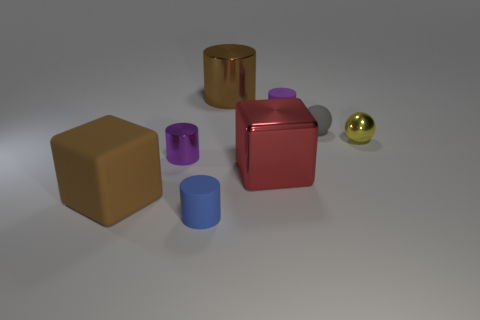Subtract all green cylinders. Subtract all purple spheres. How many cylinders are left? 4 Add 1 small cyan objects. How many objects exist? 9 Subtract all cubes. How many objects are left? 6 Subtract all metallic spheres. Subtract all spheres. How many objects are left? 5 Add 5 brown cylinders. How many brown cylinders are left? 6 Add 4 big cyan shiny cubes. How many big cyan shiny cubes exist? 4 Subtract 0 gray cylinders. How many objects are left? 8 